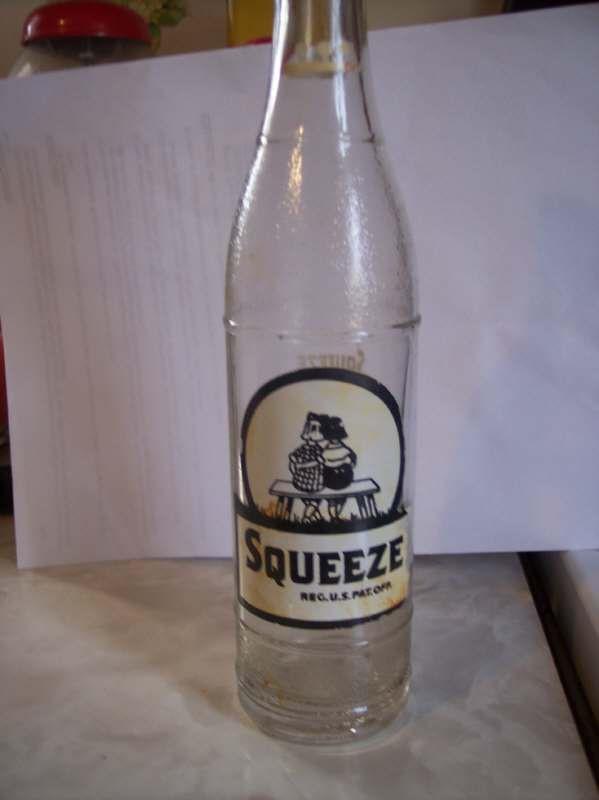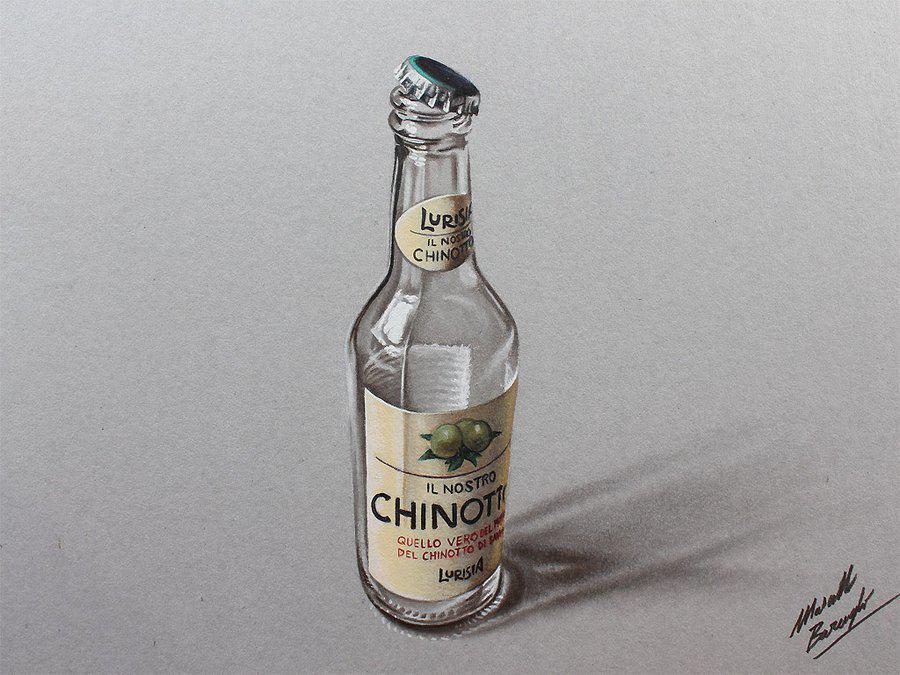The first image is the image on the left, the second image is the image on the right. Examine the images to the left and right. Is the description "One image shows a single upright, uncapped clear bottle with a colored label and ridges around the glass, and the other image shows at least six varied glass bottles without colored labels." accurate? Answer yes or no. No. The first image is the image on the left, the second image is the image on the right. Given the left and right images, does the statement "The right image contains exactly one glass bottle." hold true? Answer yes or no. Yes. 